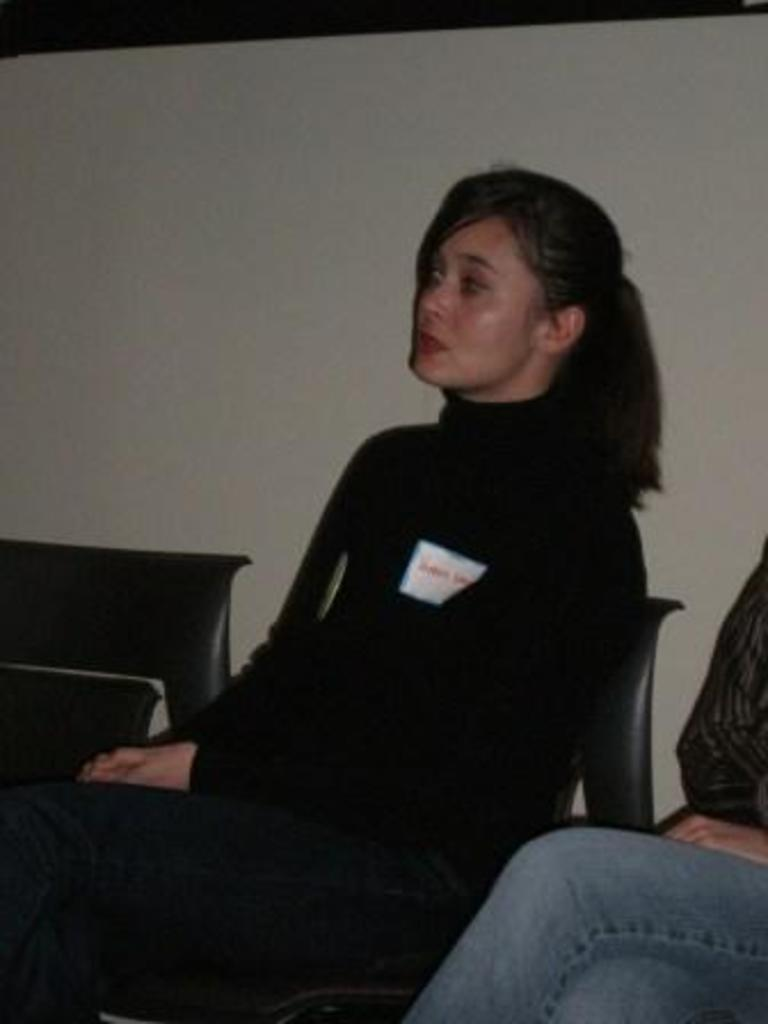What are the persons in the image doing? The persons in the image are sitting on chairs. What can be seen in the background of the image? There is a wall visible in the background of the image. What type of bait is being used by the persons in the image? There is no indication of fishing or bait in the image; the persons are simply sitting on chairs. What is the condition of the mouths of the persons in the image? There is no information about the mouths of the persons in the image, as the focus is on their sitting position. 